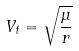<formula> <loc_0><loc_0><loc_500><loc_500>V _ { t } = \sqrt { \frac { \mu } { r } }</formula> 